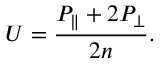Convert formula to latex. <formula><loc_0><loc_0><loc_500><loc_500>U = \frac { P _ { \| } + 2 P _ { \perp } } { 2 n } .</formula> 